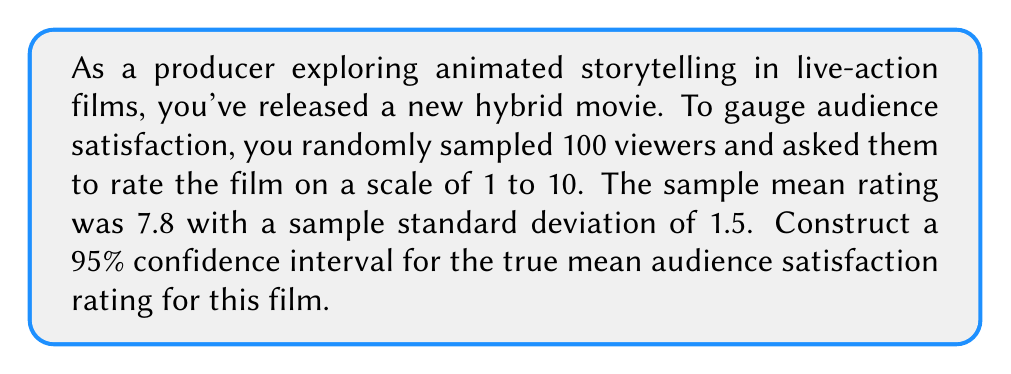Solve this math problem. To construct a 95% confidence interval for the true mean audience satisfaction rating, we'll follow these steps:

1. Identify the known values:
   - Sample size: $n = 100$
   - Sample mean: $\bar{x} = 7.8$
   - Sample standard deviation: $s = 1.5$
   - Confidence level: 95% (α = 0.05)

2. Determine the critical value:
   For a 95% confidence interval with df > 30, we use the z-score: $z_{0.025} = 1.96$

3. Calculate the margin of error:
   Margin of error = $z_{0.025} \cdot \frac{s}{\sqrt{n}}$
   $= 1.96 \cdot \frac{1.5}{\sqrt{100}}$
   $= 1.96 \cdot \frac{1.5}{10}$
   $= 1.96 \cdot 0.15$
   $= 0.294$

4. Construct the confidence interval:
   CI = $\bar{x} \pm$ margin of error
   $= 7.8 \pm 0.294$
   $= (7.506, 8.094)$

Therefore, we can be 95% confident that the true mean audience satisfaction rating for this film falls between 7.506 and 8.094 on a scale of 1 to 10.
Answer: (7.506, 8.094) 